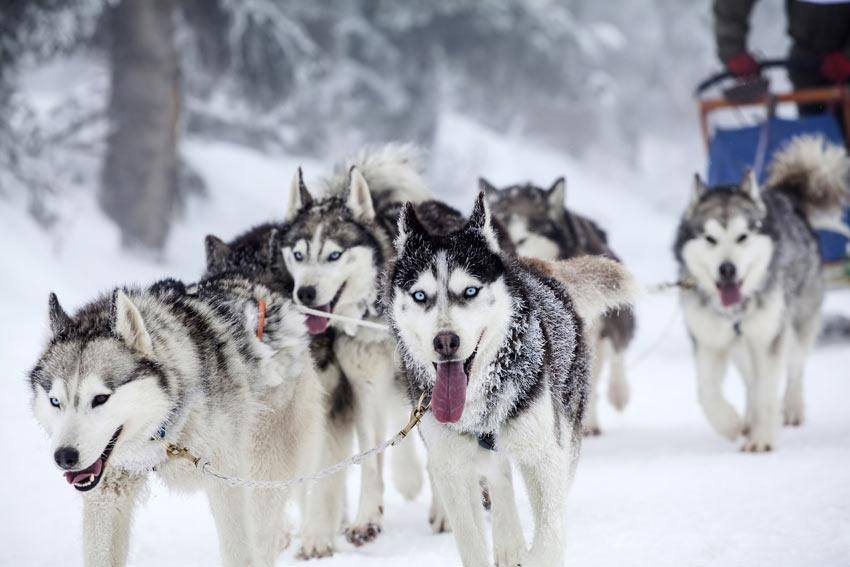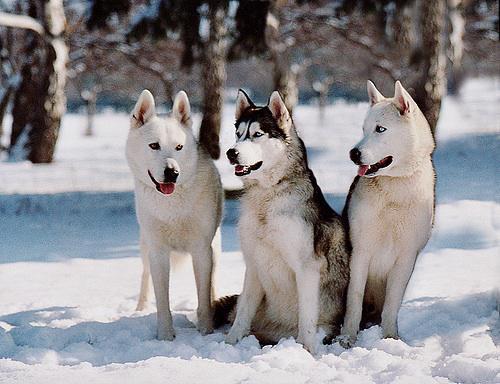The first image is the image on the left, the second image is the image on the right. Analyze the images presented: Is the assertion "One image has one dog and the other image has a pack of dogs." valid? Answer yes or no. No. The first image is the image on the left, the second image is the image on the right. For the images displayed, is the sentence "A sled is being pulled over the snow by a team of dogs in one of the images." factually correct? Answer yes or no. Yes. 